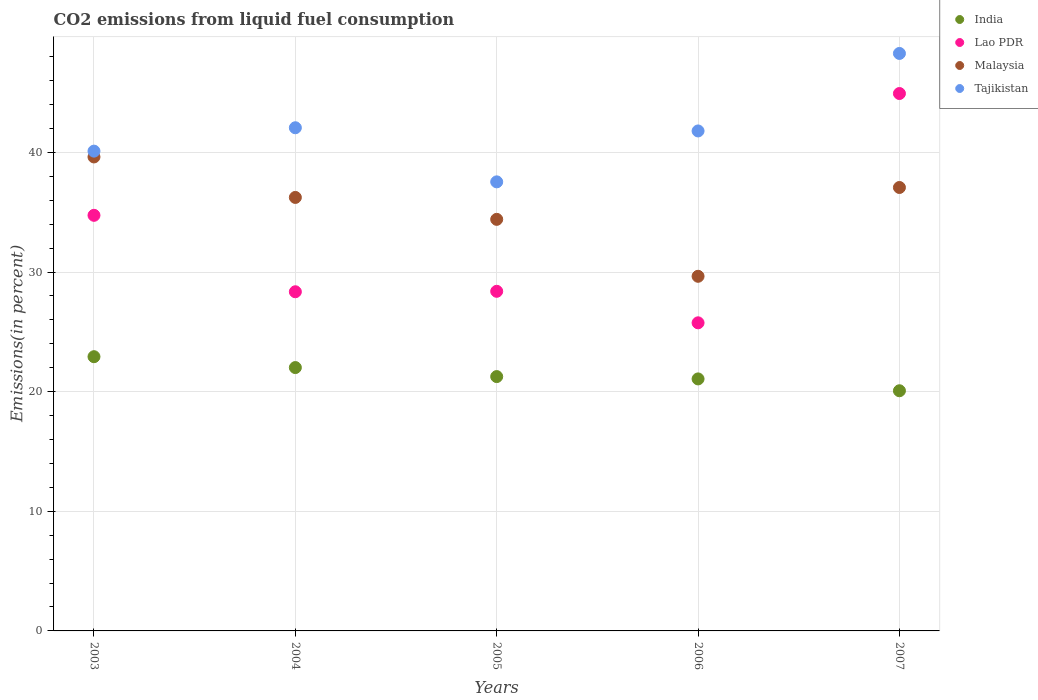How many different coloured dotlines are there?
Your answer should be very brief. 4. What is the total CO2 emitted in India in 2006?
Ensure brevity in your answer.  21.07. Across all years, what is the maximum total CO2 emitted in Malaysia?
Give a very brief answer. 39.62. Across all years, what is the minimum total CO2 emitted in Lao PDR?
Your response must be concise. 25.75. In which year was the total CO2 emitted in India minimum?
Keep it short and to the point. 2007. What is the total total CO2 emitted in Tajikistan in the graph?
Keep it short and to the point. 209.77. What is the difference between the total CO2 emitted in Malaysia in 2005 and that in 2006?
Offer a terse response. 4.76. What is the difference between the total CO2 emitted in India in 2004 and the total CO2 emitted in Tajikistan in 2003?
Ensure brevity in your answer.  -18.09. What is the average total CO2 emitted in India per year?
Offer a very short reply. 21.47. In the year 2006, what is the difference between the total CO2 emitted in Malaysia and total CO2 emitted in Tajikistan?
Your answer should be very brief. -12.15. What is the ratio of the total CO2 emitted in Malaysia in 2004 to that in 2006?
Keep it short and to the point. 1.22. Is the total CO2 emitted in Tajikistan in 2003 less than that in 2004?
Offer a terse response. Yes. Is the difference between the total CO2 emitted in Malaysia in 2003 and 2007 greater than the difference between the total CO2 emitted in Tajikistan in 2003 and 2007?
Provide a short and direct response. Yes. What is the difference between the highest and the second highest total CO2 emitted in Malaysia?
Keep it short and to the point. 2.55. What is the difference between the highest and the lowest total CO2 emitted in India?
Give a very brief answer. 2.85. In how many years, is the total CO2 emitted in Tajikistan greater than the average total CO2 emitted in Tajikistan taken over all years?
Offer a very short reply. 2. Is the sum of the total CO2 emitted in Lao PDR in 2004 and 2007 greater than the maximum total CO2 emitted in Tajikistan across all years?
Give a very brief answer. Yes. Is it the case that in every year, the sum of the total CO2 emitted in Malaysia and total CO2 emitted in Lao PDR  is greater than the sum of total CO2 emitted in Tajikistan and total CO2 emitted in India?
Your answer should be compact. No. Is it the case that in every year, the sum of the total CO2 emitted in Lao PDR and total CO2 emitted in India  is greater than the total CO2 emitted in Tajikistan?
Make the answer very short. Yes. How many dotlines are there?
Offer a very short reply. 4. How many years are there in the graph?
Your answer should be compact. 5. Does the graph contain any zero values?
Your answer should be very brief. No. Where does the legend appear in the graph?
Keep it short and to the point. Top right. How many legend labels are there?
Provide a succinct answer. 4. What is the title of the graph?
Offer a very short reply. CO2 emissions from liquid fuel consumption. What is the label or title of the X-axis?
Your answer should be very brief. Years. What is the label or title of the Y-axis?
Ensure brevity in your answer.  Emissions(in percent). What is the Emissions(in percent) in India in 2003?
Keep it short and to the point. 22.92. What is the Emissions(in percent) in Lao PDR in 2003?
Your answer should be compact. 34.74. What is the Emissions(in percent) in Malaysia in 2003?
Keep it short and to the point. 39.62. What is the Emissions(in percent) of Tajikistan in 2003?
Your answer should be compact. 40.11. What is the Emissions(in percent) in India in 2004?
Ensure brevity in your answer.  22.01. What is the Emissions(in percent) in Lao PDR in 2004?
Offer a terse response. 28.35. What is the Emissions(in percent) of Malaysia in 2004?
Ensure brevity in your answer.  36.24. What is the Emissions(in percent) of Tajikistan in 2004?
Keep it short and to the point. 42.06. What is the Emissions(in percent) of India in 2005?
Your response must be concise. 21.26. What is the Emissions(in percent) in Lao PDR in 2005?
Offer a terse response. 28.39. What is the Emissions(in percent) of Malaysia in 2005?
Provide a succinct answer. 34.4. What is the Emissions(in percent) of Tajikistan in 2005?
Ensure brevity in your answer.  37.54. What is the Emissions(in percent) of India in 2006?
Provide a short and direct response. 21.07. What is the Emissions(in percent) in Lao PDR in 2006?
Give a very brief answer. 25.75. What is the Emissions(in percent) in Malaysia in 2006?
Offer a very short reply. 29.64. What is the Emissions(in percent) in Tajikistan in 2006?
Offer a terse response. 41.79. What is the Emissions(in percent) of India in 2007?
Provide a short and direct response. 20.08. What is the Emissions(in percent) of Lao PDR in 2007?
Your response must be concise. 44.92. What is the Emissions(in percent) in Malaysia in 2007?
Provide a succinct answer. 37.07. What is the Emissions(in percent) in Tajikistan in 2007?
Provide a short and direct response. 48.27. Across all years, what is the maximum Emissions(in percent) of India?
Make the answer very short. 22.92. Across all years, what is the maximum Emissions(in percent) in Lao PDR?
Make the answer very short. 44.92. Across all years, what is the maximum Emissions(in percent) of Malaysia?
Provide a short and direct response. 39.62. Across all years, what is the maximum Emissions(in percent) in Tajikistan?
Provide a succinct answer. 48.27. Across all years, what is the minimum Emissions(in percent) of India?
Provide a succinct answer. 20.08. Across all years, what is the minimum Emissions(in percent) of Lao PDR?
Make the answer very short. 25.75. Across all years, what is the minimum Emissions(in percent) of Malaysia?
Offer a terse response. 29.64. Across all years, what is the minimum Emissions(in percent) of Tajikistan?
Ensure brevity in your answer.  37.54. What is the total Emissions(in percent) of India in the graph?
Give a very brief answer. 107.34. What is the total Emissions(in percent) of Lao PDR in the graph?
Ensure brevity in your answer.  162.16. What is the total Emissions(in percent) of Malaysia in the graph?
Keep it short and to the point. 176.97. What is the total Emissions(in percent) of Tajikistan in the graph?
Give a very brief answer. 209.77. What is the difference between the Emissions(in percent) in India in 2003 and that in 2004?
Your response must be concise. 0.91. What is the difference between the Emissions(in percent) in Lao PDR in 2003 and that in 2004?
Keep it short and to the point. 6.39. What is the difference between the Emissions(in percent) in Malaysia in 2003 and that in 2004?
Keep it short and to the point. 3.38. What is the difference between the Emissions(in percent) in Tajikistan in 2003 and that in 2004?
Make the answer very short. -1.95. What is the difference between the Emissions(in percent) in India in 2003 and that in 2005?
Provide a short and direct response. 1.66. What is the difference between the Emissions(in percent) in Lao PDR in 2003 and that in 2005?
Keep it short and to the point. 6.35. What is the difference between the Emissions(in percent) in Malaysia in 2003 and that in 2005?
Your response must be concise. 5.22. What is the difference between the Emissions(in percent) of Tajikistan in 2003 and that in 2005?
Your response must be concise. 2.57. What is the difference between the Emissions(in percent) of India in 2003 and that in 2006?
Offer a very short reply. 1.86. What is the difference between the Emissions(in percent) of Lao PDR in 2003 and that in 2006?
Offer a terse response. 8.99. What is the difference between the Emissions(in percent) in Malaysia in 2003 and that in 2006?
Your response must be concise. 9.98. What is the difference between the Emissions(in percent) of Tajikistan in 2003 and that in 2006?
Give a very brief answer. -1.69. What is the difference between the Emissions(in percent) of India in 2003 and that in 2007?
Your response must be concise. 2.85. What is the difference between the Emissions(in percent) of Lao PDR in 2003 and that in 2007?
Ensure brevity in your answer.  -10.18. What is the difference between the Emissions(in percent) of Malaysia in 2003 and that in 2007?
Provide a short and direct response. 2.55. What is the difference between the Emissions(in percent) in Tajikistan in 2003 and that in 2007?
Provide a short and direct response. -8.17. What is the difference between the Emissions(in percent) of India in 2004 and that in 2005?
Your answer should be very brief. 0.75. What is the difference between the Emissions(in percent) of Lao PDR in 2004 and that in 2005?
Offer a terse response. -0.04. What is the difference between the Emissions(in percent) of Malaysia in 2004 and that in 2005?
Offer a very short reply. 1.83. What is the difference between the Emissions(in percent) in Tajikistan in 2004 and that in 2005?
Make the answer very short. 4.52. What is the difference between the Emissions(in percent) of India in 2004 and that in 2006?
Your answer should be very brief. 0.95. What is the difference between the Emissions(in percent) of Lao PDR in 2004 and that in 2006?
Provide a short and direct response. 2.6. What is the difference between the Emissions(in percent) of Malaysia in 2004 and that in 2006?
Provide a succinct answer. 6.59. What is the difference between the Emissions(in percent) in Tajikistan in 2004 and that in 2006?
Give a very brief answer. 0.27. What is the difference between the Emissions(in percent) of India in 2004 and that in 2007?
Ensure brevity in your answer.  1.94. What is the difference between the Emissions(in percent) of Lao PDR in 2004 and that in 2007?
Your response must be concise. -16.57. What is the difference between the Emissions(in percent) of Malaysia in 2004 and that in 2007?
Make the answer very short. -0.83. What is the difference between the Emissions(in percent) in Tajikistan in 2004 and that in 2007?
Your answer should be compact. -6.21. What is the difference between the Emissions(in percent) of India in 2005 and that in 2006?
Your answer should be very brief. 0.19. What is the difference between the Emissions(in percent) of Lao PDR in 2005 and that in 2006?
Keep it short and to the point. 2.63. What is the difference between the Emissions(in percent) of Malaysia in 2005 and that in 2006?
Ensure brevity in your answer.  4.76. What is the difference between the Emissions(in percent) in Tajikistan in 2005 and that in 2006?
Your response must be concise. -4.26. What is the difference between the Emissions(in percent) in India in 2005 and that in 2007?
Your response must be concise. 1.19. What is the difference between the Emissions(in percent) in Lao PDR in 2005 and that in 2007?
Your answer should be very brief. -16.53. What is the difference between the Emissions(in percent) of Malaysia in 2005 and that in 2007?
Your response must be concise. -2.66. What is the difference between the Emissions(in percent) of Tajikistan in 2005 and that in 2007?
Your answer should be compact. -10.73. What is the difference between the Emissions(in percent) in India in 2006 and that in 2007?
Offer a terse response. 0.99. What is the difference between the Emissions(in percent) in Lao PDR in 2006 and that in 2007?
Offer a very short reply. -19.17. What is the difference between the Emissions(in percent) of Malaysia in 2006 and that in 2007?
Provide a short and direct response. -7.42. What is the difference between the Emissions(in percent) of Tajikistan in 2006 and that in 2007?
Give a very brief answer. -6.48. What is the difference between the Emissions(in percent) of India in 2003 and the Emissions(in percent) of Lao PDR in 2004?
Offer a very short reply. -5.43. What is the difference between the Emissions(in percent) of India in 2003 and the Emissions(in percent) of Malaysia in 2004?
Ensure brevity in your answer.  -13.31. What is the difference between the Emissions(in percent) in India in 2003 and the Emissions(in percent) in Tajikistan in 2004?
Provide a short and direct response. -19.14. What is the difference between the Emissions(in percent) in Lao PDR in 2003 and the Emissions(in percent) in Malaysia in 2004?
Your answer should be very brief. -1.5. What is the difference between the Emissions(in percent) in Lao PDR in 2003 and the Emissions(in percent) in Tajikistan in 2004?
Offer a terse response. -7.32. What is the difference between the Emissions(in percent) of Malaysia in 2003 and the Emissions(in percent) of Tajikistan in 2004?
Offer a terse response. -2.44. What is the difference between the Emissions(in percent) of India in 2003 and the Emissions(in percent) of Lao PDR in 2005?
Your answer should be compact. -5.47. What is the difference between the Emissions(in percent) in India in 2003 and the Emissions(in percent) in Malaysia in 2005?
Make the answer very short. -11.48. What is the difference between the Emissions(in percent) in India in 2003 and the Emissions(in percent) in Tajikistan in 2005?
Your answer should be compact. -14.61. What is the difference between the Emissions(in percent) of Lao PDR in 2003 and the Emissions(in percent) of Malaysia in 2005?
Give a very brief answer. 0.34. What is the difference between the Emissions(in percent) in Lao PDR in 2003 and the Emissions(in percent) in Tajikistan in 2005?
Offer a terse response. -2.8. What is the difference between the Emissions(in percent) of Malaysia in 2003 and the Emissions(in percent) of Tajikistan in 2005?
Make the answer very short. 2.08. What is the difference between the Emissions(in percent) in India in 2003 and the Emissions(in percent) in Lao PDR in 2006?
Provide a short and direct response. -2.83. What is the difference between the Emissions(in percent) of India in 2003 and the Emissions(in percent) of Malaysia in 2006?
Offer a terse response. -6.72. What is the difference between the Emissions(in percent) of India in 2003 and the Emissions(in percent) of Tajikistan in 2006?
Provide a succinct answer. -18.87. What is the difference between the Emissions(in percent) of Lao PDR in 2003 and the Emissions(in percent) of Malaysia in 2006?
Offer a terse response. 5.1. What is the difference between the Emissions(in percent) in Lao PDR in 2003 and the Emissions(in percent) in Tajikistan in 2006?
Make the answer very short. -7.05. What is the difference between the Emissions(in percent) in Malaysia in 2003 and the Emissions(in percent) in Tajikistan in 2006?
Your answer should be compact. -2.17. What is the difference between the Emissions(in percent) of India in 2003 and the Emissions(in percent) of Lao PDR in 2007?
Make the answer very short. -22. What is the difference between the Emissions(in percent) in India in 2003 and the Emissions(in percent) in Malaysia in 2007?
Offer a very short reply. -14.14. What is the difference between the Emissions(in percent) in India in 2003 and the Emissions(in percent) in Tajikistan in 2007?
Offer a very short reply. -25.35. What is the difference between the Emissions(in percent) of Lao PDR in 2003 and the Emissions(in percent) of Malaysia in 2007?
Keep it short and to the point. -2.33. What is the difference between the Emissions(in percent) of Lao PDR in 2003 and the Emissions(in percent) of Tajikistan in 2007?
Provide a succinct answer. -13.53. What is the difference between the Emissions(in percent) of Malaysia in 2003 and the Emissions(in percent) of Tajikistan in 2007?
Your answer should be very brief. -8.65. What is the difference between the Emissions(in percent) in India in 2004 and the Emissions(in percent) in Lao PDR in 2005?
Provide a succinct answer. -6.38. What is the difference between the Emissions(in percent) in India in 2004 and the Emissions(in percent) in Malaysia in 2005?
Your answer should be very brief. -12.39. What is the difference between the Emissions(in percent) of India in 2004 and the Emissions(in percent) of Tajikistan in 2005?
Give a very brief answer. -15.52. What is the difference between the Emissions(in percent) in Lao PDR in 2004 and the Emissions(in percent) in Malaysia in 2005?
Make the answer very short. -6.05. What is the difference between the Emissions(in percent) in Lao PDR in 2004 and the Emissions(in percent) in Tajikistan in 2005?
Offer a very short reply. -9.19. What is the difference between the Emissions(in percent) of Malaysia in 2004 and the Emissions(in percent) of Tajikistan in 2005?
Keep it short and to the point. -1.3. What is the difference between the Emissions(in percent) of India in 2004 and the Emissions(in percent) of Lao PDR in 2006?
Offer a very short reply. -3.74. What is the difference between the Emissions(in percent) in India in 2004 and the Emissions(in percent) in Malaysia in 2006?
Ensure brevity in your answer.  -7.63. What is the difference between the Emissions(in percent) in India in 2004 and the Emissions(in percent) in Tajikistan in 2006?
Offer a terse response. -19.78. What is the difference between the Emissions(in percent) in Lao PDR in 2004 and the Emissions(in percent) in Malaysia in 2006?
Make the answer very short. -1.29. What is the difference between the Emissions(in percent) in Lao PDR in 2004 and the Emissions(in percent) in Tajikistan in 2006?
Provide a succinct answer. -13.44. What is the difference between the Emissions(in percent) of Malaysia in 2004 and the Emissions(in percent) of Tajikistan in 2006?
Your answer should be compact. -5.56. What is the difference between the Emissions(in percent) in India in 2004 and the Emissions(in percent) in Lao PDR in 2007?
Give a very brief answer. -22.91. What is the difference between the Emissions(in percent) of India in 2004 and the Emissions(in percent) of Malaysia in 2007?
Offer a very short reply. -15.05. What is the difference between the Emissions(in percent) in India in 2004 and the Emissions(in percent) in Tajikistan in 2007?
Your answer should be compact. -26.26. What is the difference between the Emissions(in percent) of Lao PDR in 2004 and the Emissions(in percent) of Malaysia in 2007?
Provide a succinct answer. -8.72. What is the difference between the Emissions(in percent) of Lao PDR in 2004 and the Emissions(in percent) of Tajikistan in 2007?
Offer a very short reply. -19.92. What is the difference between the Emissions(in percent) of Malaysia in 2004 and the Emissions(in percent) of Tajikistan in 2007?
Provide a short and direct response. -12.04. What is the difference between the Emissions(in percent) in India in 2005 and the Emissions(in percent) in Lao PDR in 2006?
Your answer should be compact. -4.49. What is the difference between the Emissions(in percent) of India in 2005 and the Emissions(in percent) of Malaysia in 2006?
Provide a short and direct response. -8.38. What is the difference between the Emissions(in percent) in India in 2005 and the Emissions(in percent) in Tajikistan in 2006?
Your response must be concise. -20.53. What is the difference between the Emissions(in percent) in Lao PDR in 2005 and the Emissions(in percent) in Malaysia in 2006?
Your response must be concise. -1.25. What is the difference between the Emissions(in percent) in Lao PDR in 2005 and the Emissions(in percent) in Tajikistan in 2006?
Offer a very short reply. -13.4. What is the difference between the Emissions(in percent) of Malaysia in 2005 and the Emissions(in percent) of Tajikistan in 2006?
Your answer should be compact. -7.39. What is the difference between the Emissions(in percent) in India in 2005 and the Emissions(in percent) in Lao PDR in 2007?
Your answer should be compact. -23.66. What is the difference between the Emissions(in percent) of India in 2005 and the Emissions(in percent) of Malaysia in 2007?
Your answer should be compact. -15.81. What is the difference between the Emissions(in percent) in India in 2005 and the Emissions(in percent) in Tajikistan in 2007?
Make the answer very short. -27.01. What is the difference between the Emissions(in percent) of Lao PDR in 2005 and the Emissions(in percent) of Malaysia in 2007?
Make the answer very short. -8.68. What is the difference between the Emissions(in percent) in Lao PDR in 2005 and the Emissions(in percent) in Tajikistan in 2007?
Your response must be concise. -19.88. What is the difference between the Emissions(in percent) of Malaysia in 2005 and the Emissions(in percent) of Tajikistan in 2007?
Provide a succinct answer. -13.87. What is the difference between the Emissions(in percent) of India in 2006 and the Emissions(in percent) of Lao PDR in 2007?
Your response must be concise. -23.86. What is the difference between the Emissions(in percent) of India in 2006 and the Emissions(in percent) of Malaysia in 2007?
Your answer should be compact. -16. What is the difference between the Emissions(in percent) of India in 2006 and the Emissions(in percent) of Tajikistan in 2007?
Offer a terse response. -27.21. What is the difference between the Emissions(in percent) of Lao PDR in 2006 and the Emissions(in percent) of Malaysia in 2007?
Make the answer very short. -11.31. What is the difference between the Emissions(in percent) of Lao PDR in 2006 and the Emissions(in percent) of Tajikistan in 2007?
Offer a very short reply. -22.52. What is the difference between the Emissions(in percent) in Malaysia in 2006 and the Emissions(in percent) in Tajikistan in 2007?
Ensure brevity in your answer.  -18.63. What is the average Emissions(in percent) of India per year?
Ensure brevity in your answer.  21.47. What is the average Emissions(in percent) of Lao PDR per year?
Your answer should be very brief. 32.43. What is the average Emissions(in percent) of Malaysia per year?
Offer a terse response. 35.39. What is the average Emissions(in percent) of Tajikistan per year?
Offer a very short reply. 41.95. In the year 2003, what is the difference between the Emissions(in percent) of India and Emissions(in percent) of Lao PDR?
Provide a short and direct response. -11.82. In the year 2003, what is the difference between the Emissions(in percent) in India and Emissions(in percent) in Malaysia?
Offer a terse response. -16.7. In the year 2003, what is the difference between the Emissions(in percent) in India and Emissions(in percent) in Tajikistan?
Offer a very short reply. -17.18. In the year 2003, what is the difference between the Emissions(in percent) in Lao PDR and Emissions(in percent) in Malaysia?
Make the answer very short. -4.88. In the year 2003, what is the difference between the Emissions(in percent) of Lao PDR and Emissions(in percent) of Tajikistan?
Give a very brief answer. -5.37. In the year 2003, what is the difference between the Emissions(in percent) in Malaysia and Emissions(in percent) in Tajikistan?
Ensure brevity in your answer.  -0.49. In the year 2004, what is the difference between the Emissions(in percent) in India and Emissions(in percent) in Lao PDR?
Provide a succinct answer. -6.34. In the year 2004, what is the difference between the Emissions(in percent) in India and Emissions(in percent) in Malaysia?
Your response must be concise. -14.22. In the year 2004, what is the difference between the Emissions(in percent) in India and Emissions(in percent) in Tajikistan?
Your answer should be compact. -20.05. In the year 2004, what is the difference between the Emissions(in percent) in Lao PDR and Emissions(in percent) in Malaysia?
Your answer should be compact. -7.88. In the year 2004, what is the difference between the Emissions(in percent) in Lao PDR and Emissions(in percent) in Tajikistan?
Make the answer very short. -13.71. In the year 2004, what is the difference between the Emissions(in percent) in Malaysia and Emissions(in percent) in Tajikistan?
Offer a terse response. -5.82. In the year 2005, what is the difference between the Emissions(in percent) in India and Emissions(in percent) in Lao PDR?
Offer a very short reply. -7.13. In the year 2005, what is the difference between the Emissions(in percent) of India and Emissions(in percent) of Malaysia?
Offer a very short reply. -13.14. In the year 2005, what is the difference between the Emissions(in percent) in India and Emissions(in percent) in Tajikistan?
Give a very brief answer. -16.28. In the year 2005, what is the difference between the Emissions(in percent) in Lao PDR and Emissions(in percent) in Malaysia?
Your answer should be very brief. -6.01. In the year 2005, what is the difference between the Emissions(in percent) of Lao PDR and Emissions(in percent) of Tajikistan?
Keep it short and to the point. -9.15. In the year 2005, what is the difference between the Emissions(in percent) in Malaysia and Emissions(in percent) in Tajikistan?
Your answer should be very brief. -3.13. In the year 2006, what is the difference between the Emissions(in percent) in India and Emissions(in percent) in Lao PDR?
Your answer should be very brief. -4.69. In the year 2006, what is the difference between the Emissions(in percent) in India and Emissions(in percent) in Malaysia?
Provide a succinct answer. -8.58. In the year 2006, what is the difference between the Emissions(in percent) in India and Emissions(in percent) in Tajikistan?
Offer a very short reply. -20.73. In the year 2006, what is the difference between the Emissions(in percent) of Lao PDR and Emissions(in percent) of Malaysia?
Your answer should be very brief. -3.89. In the year 2006, what is the difference between the Emissions(in percent) in Lao PDR and Emissions(in percent) in Tajikistan?
Ensure brevity in your answer.  -16.04. In the year 2006, what is the difference between the Emissions(in percent) in Malaysia and Emissions(in percent) in Tajikistan?
Your answer should be very brief. -12.15. In the year 2007, what is the difference between the Emissions(in percent) in India and Emissions(in percent) in Lao PDR?
Provide a short and direct response. -24.85. In the year 2007, what is the difference between the Emissions(in percent) of India and Emissions(in percent) of Malaysia?
Offer a terse response. -16.99. In the year 2007, what is the difference between the Emissions(in percent) of India and Emissions(in percent) of Tajikistan?
Your response must be concise. -28.2. In the year 2007, what is the difference between the Emissions(in percent) in Lao PDR and Emissions(in percent) in Malaysia?
Your response must be concise. 7.86. In the year 2007, what is the difference between the Emissions(in percent) in Lao PDR and Emissions(in percent) in Tajikistan?
Your answer should be very brief. -3.35. In the year 2007, what is the difference between the Emissions(in percent) in Malaysia and Emissions(in percent) in Tajikistan?
Offer a terse response. -11.21. What is the ratio of the Emissions(in percent) of India in 2003 to that in 2004?
Give a very brief answer. 1.04. What is the ratio of the Emissions(in percent) of Lao PDR in 2003 to that in 2004?
Your answer should be compact. 1.23. What is the ratio of the Emissions(in percent) in Malaysia in 2003 to that in 2004?
Ensure brevity in your answer.  1.09. What is the ratio of the Emissions(in percent) in Tajikistan in 2003 to that in 2004?
Your answer should be compact. 0.95. What is the ratio of the Emissions(in percent) of India in 2003 to that in 2005?
Your answer should be very brief. 1.08. What is the ratio of the Emissions(in percent) of Lao PDR in 2003 to that in 2005?
Give a very brief answer. 1.22. What is the ratio of the Emissions(in percent) of Malaysia in 2003 to that in 2005?
Provide a short and direct response. 1.15. What is the ratio of the Emissions(in percent) in Tajikistan in 2003 to that in 2005?
Give a very brief answer. 1.07. What is the ratio of the Emissions(in percent) of India in 2003 to that in 2006?
Provide a succinct answer. 1.09. What is the ratio of the Emissions(in percent) in Lao PDR in 2003 to that in 2006?
Offer a very short reply. 1.35. What is the ratio of the Emissions(in percent) of Malaysia in 2003 to that in 2006?
Offer a very short reply. 1.34. What is the ratio of the Emissions(in percent) in Tajikistan in 2003 to that in 2006?
Your answer should be very brief. 0.96. What is the ratio of the Emissions(in percent) of India in 2003 to that in 2007?
Your answer should be very brief. 1.14. What is the ratio of the Emissions(in percent) in Lao PDR in 2003 to that in 2007?
Your response must be concise. 0.77. What is the ratio of the Emissions(in percent) in Malaysia in 2003 to that in 2007?
Give a very brief answer. 1.07. What is the ratio of the Emissions(in percent) of Tajikistan in 2003 to that in 2007?
Provide a short and direct response. 0.83. What is the ratio of the Emissions(in percent) of India in 2004 to that in 2005?
Offer a very short reply. 1.04. What is the ratio of the Emissions(in percent) in Lao PDR in 2004 to that in 2005?
Provide a succinct answer. 1. What is the ratio of the Emissions(in percent) of Malaysia in 2004 to that in 2005?
Your response must be concise. 1.05. What is the ratio of the Emissions(in percent) in Tajikistan in 2004 to that in 2005?
Provide a succinct answer. 1.12. What is the ratio of the Emissions(in percent) in India in 2004 to that in 2006?
Keep it short and to the point. 1.04. What is the ratio of the Emissions(in percent) of Lao PDR in 2004 to that in 2006?
Your response must be concise. 1.1. What is the ratio of the Emissions(in percent) of Malaysia in 2004 to that in 2006?
Your answer should be compact. 1.22. What is the ratio of the Emissions(in percent) in Tajikistan in 2004 to that in 2006?
Keep it short and to the point. 1.01. What is the ratio of the Emissions(in percent) of India in 2004 to that in 2007?
Offer a very short reply. 1.1. What is the ratio of the Emissions(in percent) of Lao PDR in 2004 to that in 2007?
Keep it short and to the point. 0.63. What is the ratio of the Emissions(in percent) in Malaysia in 2004 to that in 2007?
Provide a succinct answer. 0.98. What is the ratio of the Emissions(in percent) in Tajikistan in 2004 to that in 2007?
Ensure brevity in your answer.  0.87. What is the ratio of the Emissions(in percent) of India in 2005 to that in 2006?
Provide a succinct answer. 1.01. What is the ratio of the Emissions(in percent) in Lao PDR in 2005 to that in 2006?
Keep it short and to the point. 1.1. What is the ratio of the Emissions(in percent) of Malaysia in 2005 to that in 2006?
Offer a terse response. 1.16. What is the ratio of the Emissions(in percent) of Tajikistan in 2005 to that in 2006?
Make the answer very short. 0.9. What is the ratio of the Emissions(in percent) of India in 2005 to that in 2007?
Offer a very short reply. 1.06. What is the ratio of the Emissions(in percent) in Lao PDR in 2005 to that in 2007?
Ensure brevity in your answer.  0.63. What is the ratio of the Emissions(in percent) of Malaysia in 2005 to that in 2007?
Keep it short and to the point. 0.93. What is the ratio of the Emissions(in percent) of Tajikistan in 2005 to that in 2007?
Make the answer very short. 0.78. What is the ratio of the Emissions(in percent) in India in 2006 to that in 2007?
Your response must be concise. 1.05. What is the ratio of the Emissions(in percent) in Lao PDR in 2006 to that in 2007?
Your response must be concise. 0.57. What is the ratio of the Emissions(in percent) of Malaysia in 2006 to that in 2007?
Your answer should be very brief. 0.8. What is the ratio of the Emissions(in percent) of Tajikistan in 2006 to that in 2007?
Your response must be concise. 0.87. What is the difference between the highest and the second highest Emissions(in percent) of India?
Ensure brevity in your answer.  0.91. What is the difference between the highest and the second highest Emissions(in percent) in Lao PDR?
Your answer should be very brief. 10.18. What is the difference between the highest and the second highest Emissions(in percent) in Malaysia?
Offer a terse response. 2.55. What is the difference between the highest and the second highest Emissions(in percent) in Tajikistan?
Your response must be concise. 6.21. What is the difference between the highest and the lowest Emissions(in percent) in India?
Your answer should be compact. 2.85. What is the difference between the highest and the lowest Emissions(in percent) of Lao PDR?
Your response must be concise. 19.17. What is the difference between the highest and the lowest Emissions(in percent) in Malaysia?
Keep it short and to the point. 9.98. What is the difference between the highest and the lowest Emissions(in percent) of Tajikistan?
Your answer should be very brief. 10.73. 